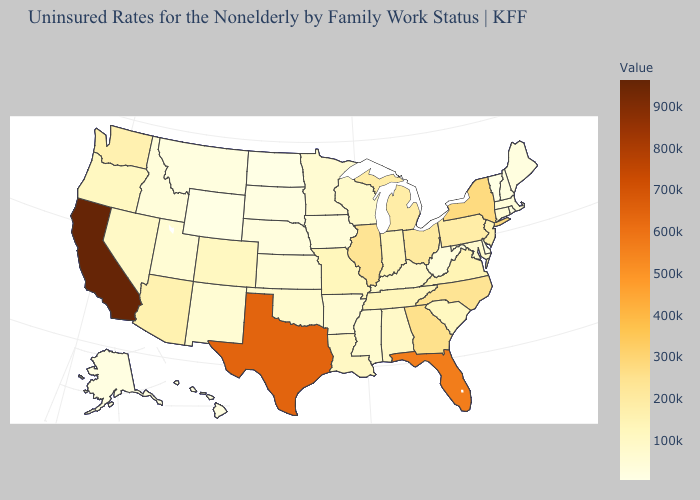Among the states that border New Mexico , does Colorado have the lowest value?
Keep it brief. No. Which states have the lowest value in the South?
Give a very brief answer. Delaware. Which states have the lowest value in the USA?
Quick response, please. Vermont. Does Michigan have the highest value in the USA?
Quick response, please. No. Does Tennessee have a lower value than Texas?
Quick response, please. Yes. 